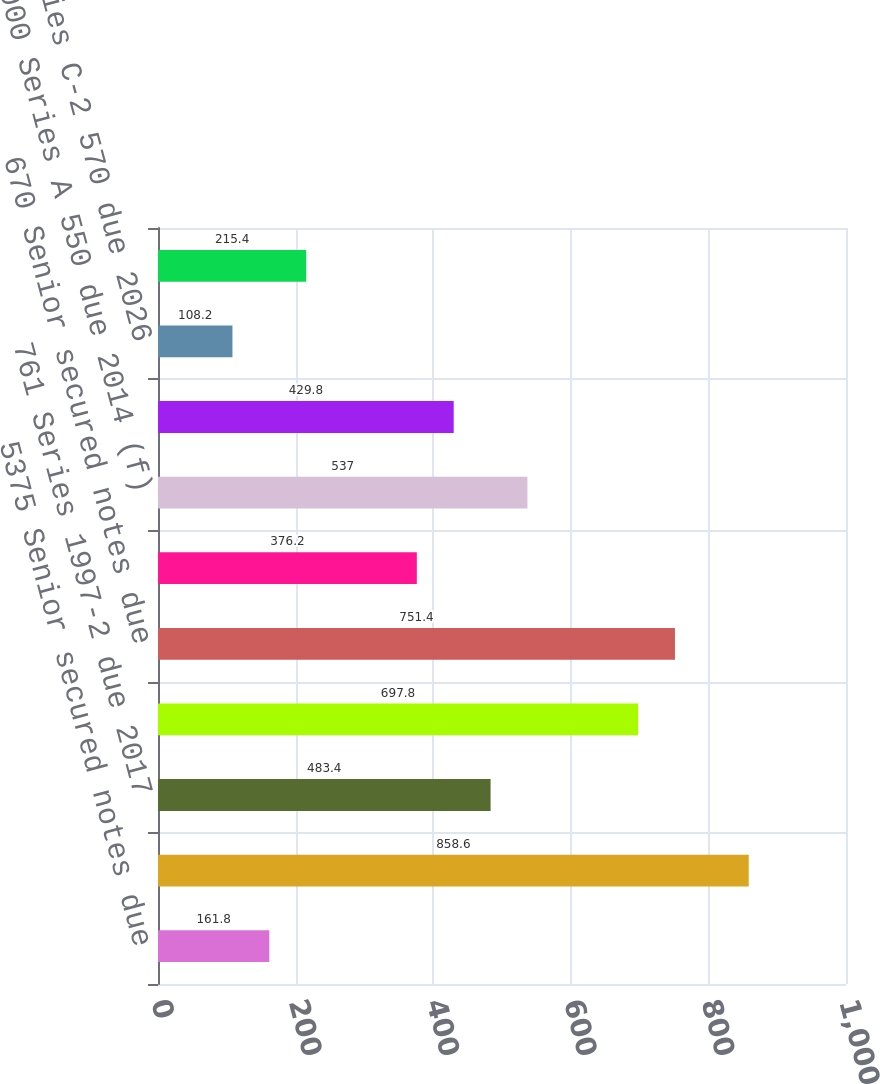Convert chart to OTSL. <chart><loc_0><loc_0><loc_500><loc_500><bar_chart><fcel>5375 Senior secured notes due<fcel>6625 Senior secured notes due<fcel>761 Series 1997-2 due 2017<fcel>6125 Senior secured notes due<fcel>670 Senior secured notes due<fcel>2004 Series due 2025<fcel>2000 Series A 550 due 2014 (f)<fcel>1993 Series C-1 595 due 2026<fcel>1993 Series C-2 570 due 2026<fcel>1993 Series B-1 due 2028 (d)<nl><fcel>161.8<fcel>858.6<fcel>483.4<fcel>697.8<fcel>751.4<fcel>376.2<fcel>537<fcel>429.8<fcel>108.2<fcel>215.4<nl></chart> 